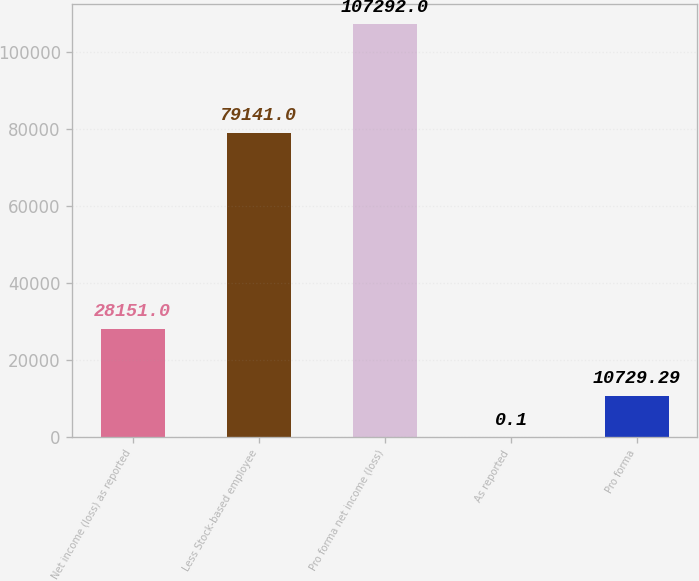Convert chart to OTSL. <chart><loc_0><loc_0><loc_500><loc_500><bar_chart><fcel>Net income (loss) as reported<fcel>Less Stock-based employee<fcel>Pro forma net income (loss)<fcel>As reported<fcel>Pro forma<nl><fcel>28151<fcel>79141<fcel>107292<fcel>0.1<fcel>10729.3<nl></chart> 